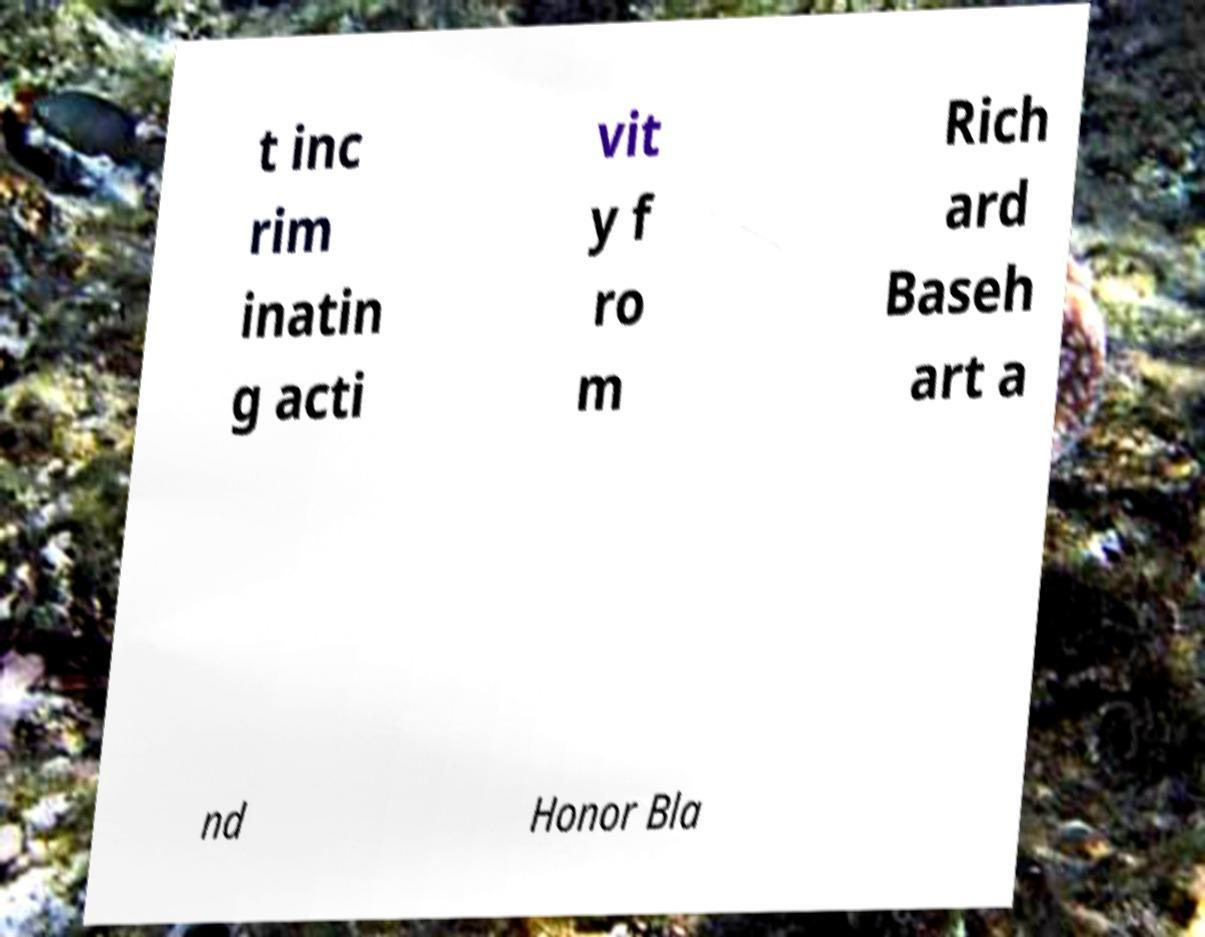Can you accurately transcribe the text from the provided image for me? t inc rim inatin g acti vit y f ro m Rich ard Baseh art a nd Honor Bla 